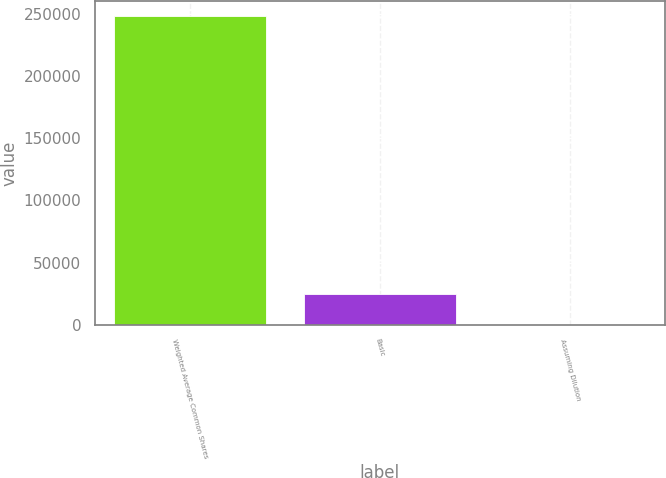<chart> <loc_0><loc_0><loc_500><loc_500><bar_chart><fcel>Weighted Average Common Shares<fcel>Basic<fcel>Assuming Dilution<nl><fcel>247855<fcel>24788.6<fcel>3.5<nl></chart> 